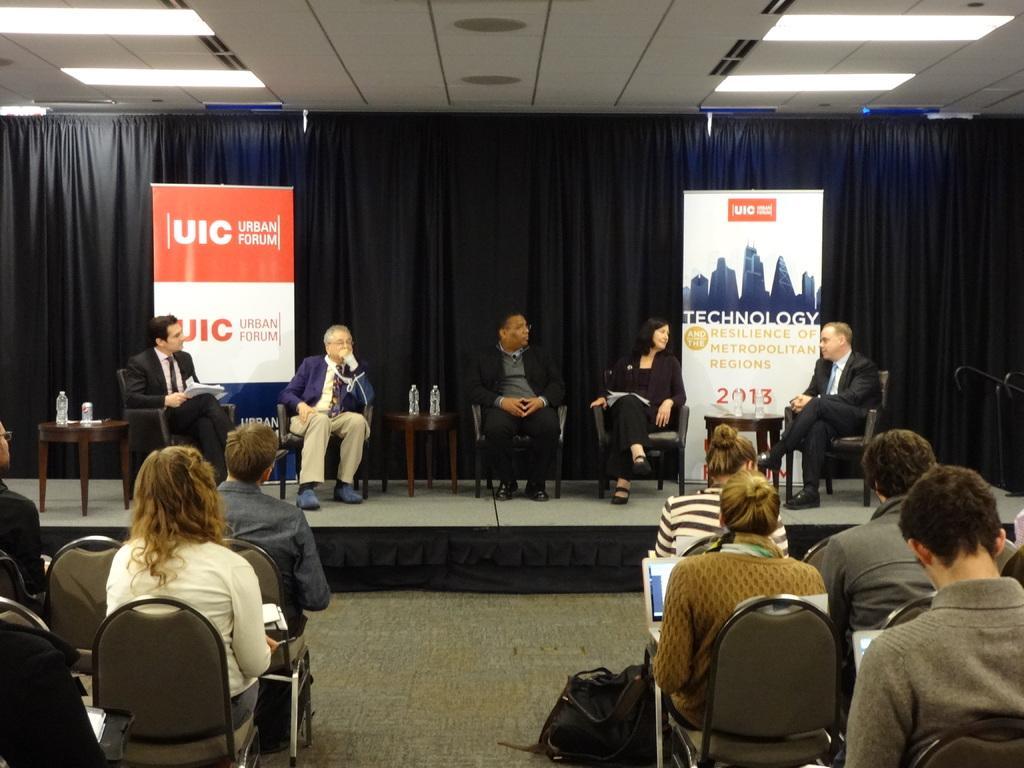Please provide a concise description of this image. In this image, we can see people sitting on the chairs and we can see bottles and there are some other objects on the stands. In the background, there are banners and we can see a curtain. At the top, there are lights and at the bottom, there is a bag on the floor. 